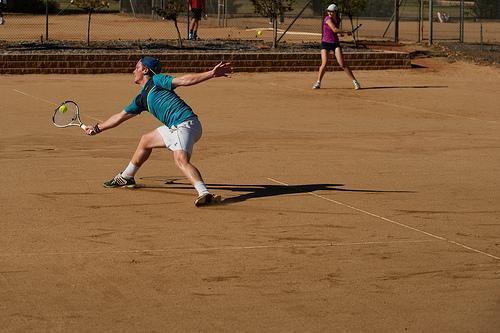How many players are in the photo?
Give a very brief answer. 2. 